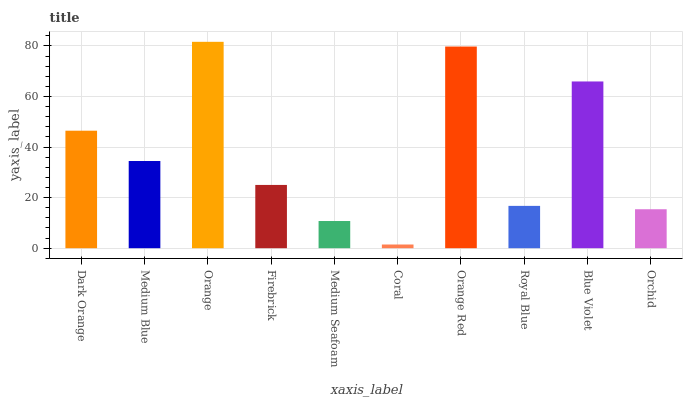Is Coral the minimum?
Answer yes or no. Yes. Is Orange the maximum?
Answer yes or no. Yes. Is Medium Blue the minimum?
Answer yes or no. No. Is Medium Blue the maximum?
Answer yes or no. No. Is Dark Orange greater than Medium Blue?
Answer yes or no. Yes. Is Medium Blue less than Dark Orange?
Answer yes or no. Yes. Is Medium Blue greater than Dark Orange?
Answer yes or no. No. Is Dark Orange less than Medium Blue?
Answer yes or no. No. Is Medium Blue the high median?
Answer yes or no. Yes. Is Firebrick the low median?
Answer yes or no. Yes. Is Medium Seafoam the high median?
Answer yes or no. No. Is Orchid the low median?
Answer yes or no. No. 